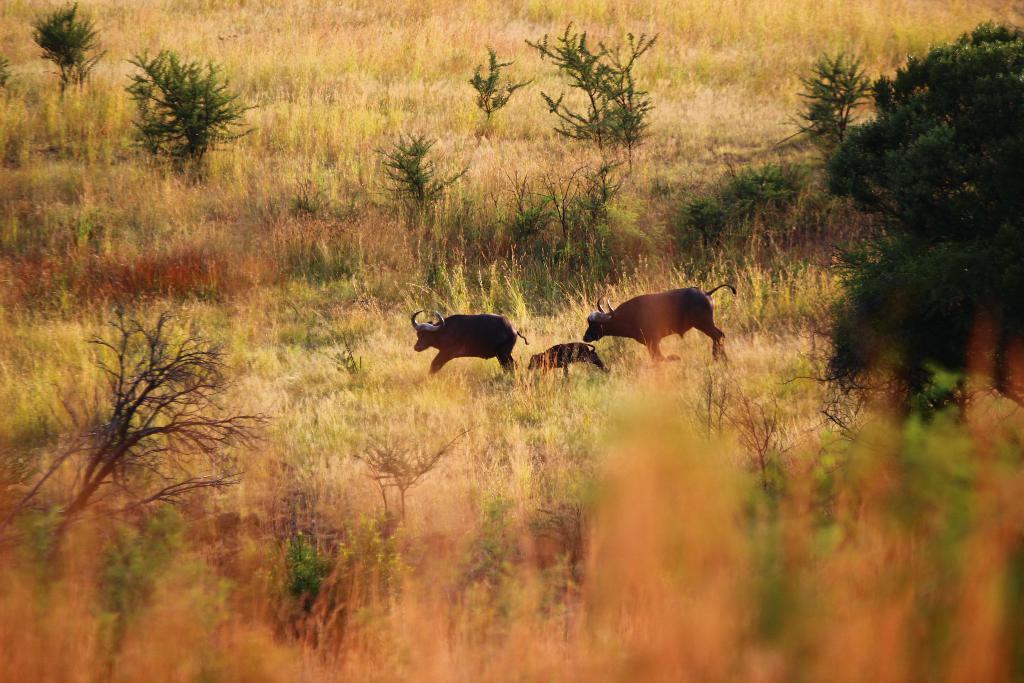Could you give a brief overview of what you see in this image? In this image we can see buffaloes running on the ground and we can see plants, grass and a tree are on the ground. 